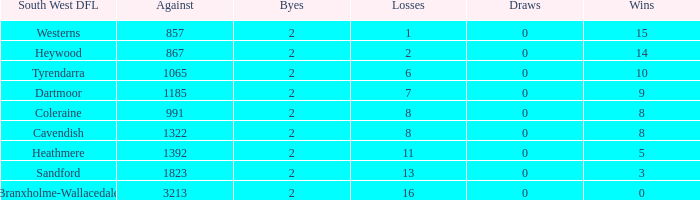How many draws does a south west dfl of tyrendarra have with fewer than 10 victories? None. 